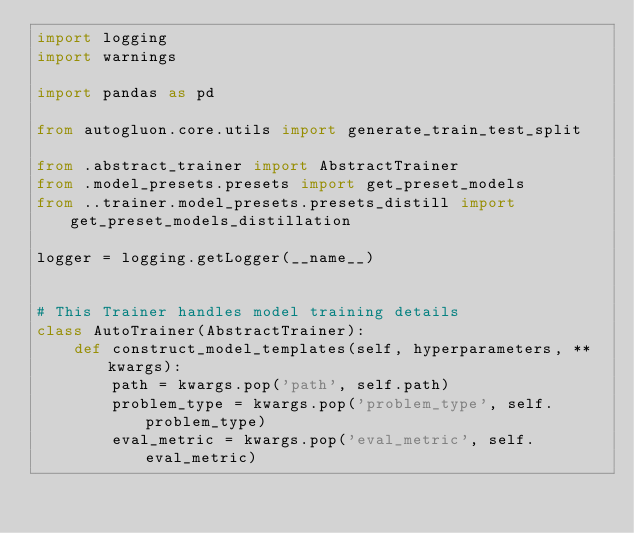<code> <loc_0><loc_0><loc_500><loc_500><_Python_>import logging
import warnings

import pandas as pd

from autogluon.core.utils import generate_train_test_split

from .abstract_trainer import AbstractTrainer
from .model_presets.presets import get_preset_models
from ..trainer.model_presets.presets_distill import get_preset_models_distillation

logger = logging.getLogger(__name__)


# This Trainer handles model training details
class AutoTrainer(AbstractTrainer):
    def construct_model_templates(self, hyperparameters, **kwargs):
        path = kwargs.pop('path', self.path)
        problem_type = kwargs.pop('problem_type', self.problem_type)
        eval_metric = kwargs.pop('eval_metric', self.eval_metric)</code> 